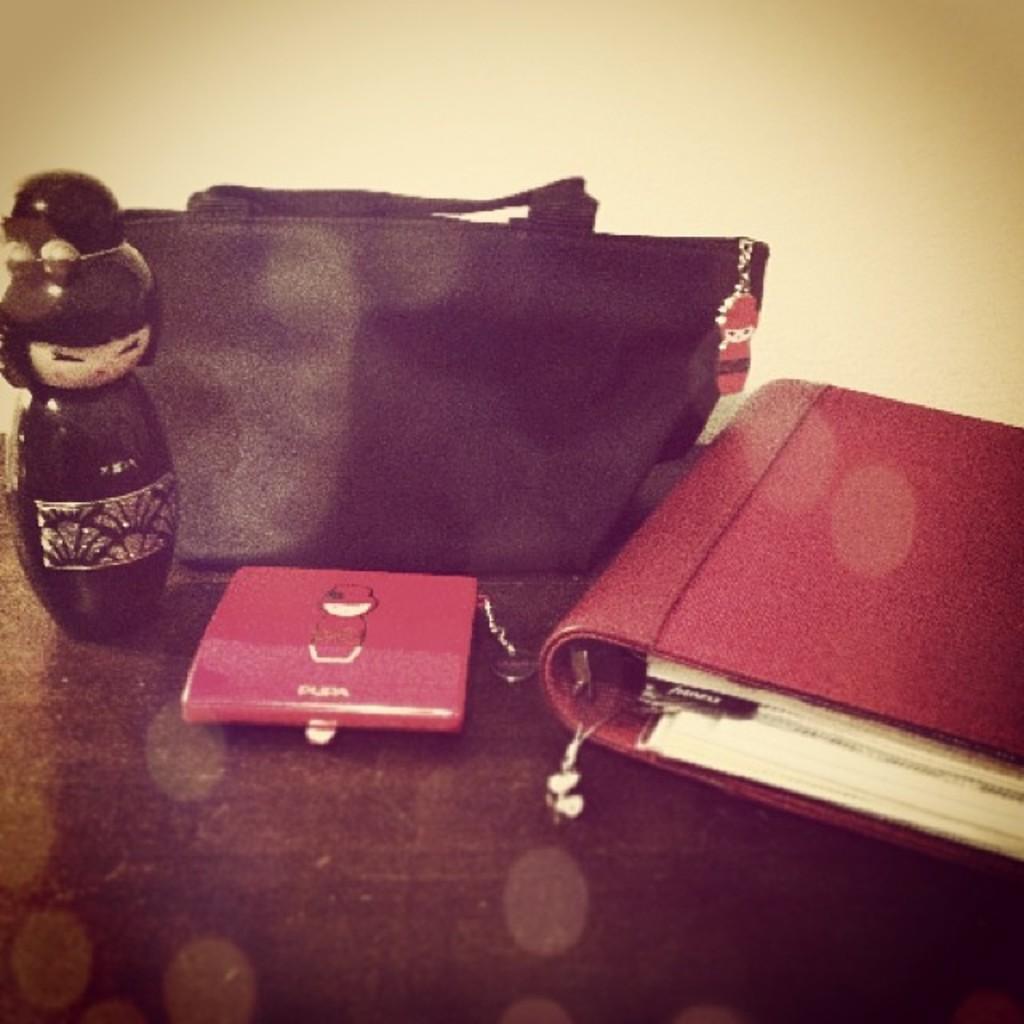Please provide a concise description of this image. This is the wooden table. I can see a black color hand bag,file which is red in color,a red object and a women bani toy which is black in color are placed on the table. And the background is white in color. 